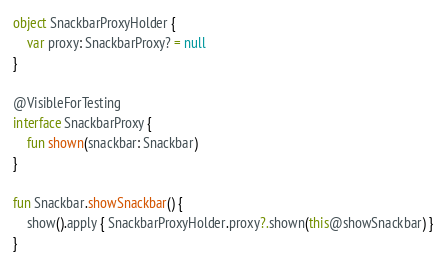Convert code to text. <code><loc_0><loc_0><loc_500><loc_500><_Kotlin_>object SnackbarProxyHolder {
    var proxy: SnackbarProxy? = null
}

@VisibleForTesting
interface SnackbarProxy {
    fun shown(snackbar: Snackbar)
}

fun Snackbar.showSnackbar() {
    show().apply { SnackbarProxyHolder.proxy?.shown(this@showSnackbar) }
}
</code> 